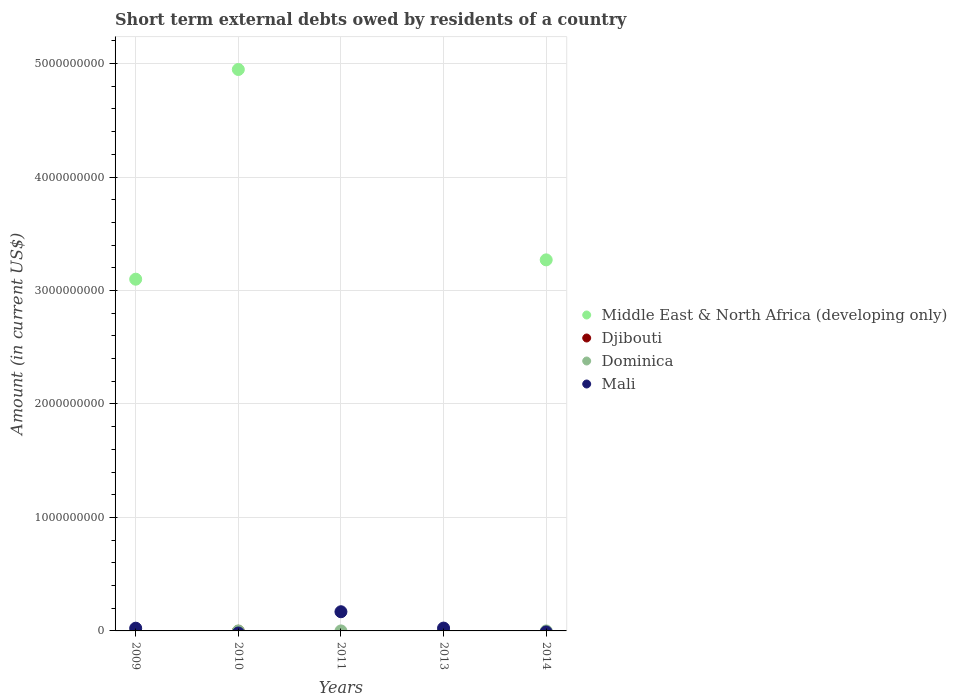Across all years, what is the maximum amount of short-term external debts owed by residents in Middle East & North Africa (developing only)?
Provide a succinct answer. 4.95e+09. Across all years, what is the minimum amount of short-term external debts owed by residents in Middle East & North Africa (developing only)?
Offer a terse response. 0. In which year was the amount of short-term external debts owed by residents in Dominica maximum?
Provide a succinct answer. 2011. What is the total amount of short-term external debts owed by residents in Mali in the graph?
Offer a terse response. 2.18e+08. What is the difference between the amount of short-term external debts owed by residents in Middle East & North Africa (developing only) in 2009 and that in 2010?
Give a very brief answer. -1.85e+09. What is the average amount of short-term external debts owed by residents in Mali per year?
Provide a succinct answer. 4.36e+07. In the year 2013, what is the difference between the amount of short-term external debts owed by residents in Dominica and amount of short-term external debts owed by residents in Mali?
Provide a succinct answer. -2.50e+07. In how many years, is the amount of short-term external debts owed by residents in Middle East & North Africa (developing only) greater than 1800000000 US$?
Offer a very short reply. 3. What is the difference between the highest and the second highest amount of short-term external debts owed by residents in Mali?
Your answer should be very brief. 1.44e+08. What is the difference between the highest and the lowest amount of short-term external debts owed by residents in Middle East & North Africa (developing only)?
Ensure brevity in your answer.  4.95e+09. In how many years, is the amount of short-term external debts owed by residents in Djibouti greater than the average amount of short-term external debts owed by residents in Djibouti taken over all years?
Give a very brief answer. 0. Is the sum of the amount of short-term external debts owed by residents in Mali in 2011 and 2013 greater than the maximum amount of short-term external debts owed by residents in Middle East & North Africa (developing only) across all years?
Your answer should be very brief. No. Is it the case that in every year, the sum of the amount of short-term external debts owed by residents in Dominica and amount of short-term external debts owed by residents in Middle East & North Africa (developing only)  is greater than the sum of amount of short-term external debts owed by residents in Mali and amount of short-term external debts owed by residents in Djibouti?
Offer a very short reply. No. Does the amount of short-term external debts owed by residents in Middle East & North Africa (developing only) monotonically increase over the years?
Your answer should be very brief. No. Is the amount of short-term external debts owed by residents in Dominica strictly greater than the amount of short-term external debts owed by residents in Middle East & North Africa (developing only) over the years?
Your answer should be compact. No. How many years are there in the graph?
Your response must be concise. 5. Does the graph contain any zero values?
Give a very brief answer. Yes. Where does the legend appear in the graph?
Provide a succinct answer. Center right. How many legend labels are there?
Offer a terse response. 4. How are the legend labels stacked?
Your response must be concise. Vertical. What is the title of the graph?
Your answer should be compact. Short term external debts owed by residents of a country. Does "Ghana" appear as one of the legend labels in the graph?
Your answer should be compact. No. What is the Amount (in current US$) in Middle East & North Africa (developing only) in 2009?
Keep it short and to the point. 3.10e+09. What is the Amount (in current US$) in Djibouti in 2009?
Offer a very short reply. 0. What is the Amount (in current US$) in Mali in 2009?
Provide a succinct answer. 2.40e+07. What is the Amount (in current US$) of Middle East & North Africa (developing only) in 2010?
Your response must be concise. 4.95e+09. What is the Amount (in current US$) in Mali in 2010?
Offer a terse response. 0. What is the Amount (in current US$) of Middle East & North Africa (developing only) in 2011?
Give a very brief answer. 0. What is the Amount (in current US$) of Djibouti in 2011?
Keep it short and to the point. 0. What is the Amount (in current US$) of Dominica in 2011?
Offer a very short reply. 10000. What is the Amount (in current US$) of Mali in 2011?
Offer a terse response. 1.69e+08. What is the Amount (in current US$) in Middle East & North Africa (developing only) in 2013?
Ensure brevity in your answer.  0. What is the Amount (in current US$) of Djibouti in 2013?
Your response must be concise. 0. What is the Amount (in current US$) of Dominica in 2013?
Offer a terse response. 4000. What is the Amount (in current US$) of Mali in 2013?
Give a very brief answer. 2.50e+07. What is the Amount (in current US$) of Middle East & North Africa (developing only) in 2014?
Offer a very short reply. 3.27e+09. What is the Amount (in current US$) of Dominica in 2014?
Offer a terse response. 0. What is the Amount (in current US$) of Mali in 2014?
Offer a very short reply. 0. Across all years, what is the maximum Amount (in current US$) of Middle East & North Africa (developing only)?
Keep it short and to the point. 4.95e+09. Across all years, what is the maximum Amount (in current US$) of Mali?
Offer a very short reply. 1.69e+08. What is the total Amount (in current US$) of Middle East & North Africa (developing only) in the graph?
Offer a very short reply. 1.13e+1. What is the total Amount (in current US$) in Dominica in the graph?
Make the answer very short. 1.40e+04. What is the total Amount (in current US$) of Mali in the graph?
Ensure brevity in your answer.  2.18e+08. What is the difference between the Amount (in current US$) in Middle East & North Africa (developing only) in 2009 and that in 2010?
Your answer should be very brief. -1.85e+09. What is the difference between the Amount (in current US$) in Mali in 2009 and that in 2011?
Offer a very short reply. -1.45e+08. What is the difference between the Amount (in current US$) of Mali in 2009 and that in 2013?
Provide a succinct answer. -1.00e+06. What is the difference between the Amount (in current US$) in Middle East & North Africa (developing only) in 2009 and that in 2014?
Offer a very short reply. -1.70e+08. What is the difference between the Amount (in current US$) of Middle East & North Africa (developing only) in 2010 and that in 2014?
Give a very brief answer. 1.68e+09. What is the difference between the Amount (in current US$) in Dominica in 2011 and that in 2013?
Keep it short and to the point. 6000. What is the difference between the Amount (in current US$) of Mali in 2011 and that in 2013?
Your answer should be compact. 1.44e+08. What is the difference between the Amount (in current US$) in Middle East & North Africa (developing only) in 2009 and the Amount (in current US$) in Dominica in 2011?
Your answer should be compact. 3.10e+09. What is the difference between the Amount (in current US$) in Middle East & North Africa (developing only) in 2009 and the Amount (in current US$) in Mali in 2011?
Offer a terse response. 2.93e+09. What is the difference between the Amount (in current US$) in Middle East & North Africa (developing only) in 2009 and the Amount (in current US$) in Dominica in 2013?
Keep it short and to the point. 3.10e+09. What is the difference between the Amount (in current US$) of Middle East & North Africa (developing only) in 2009 and the Amount (in current US$) of Mali in 2013?
Give a very brief answer. 3.07e+09. What is the difference between the Amount (in current US$) of Middle East & North Africa (developing only) in 2010 and the Amount (in current US$) of Dominica in 2011?
Your answer should be compact. 4.95e+09. What is the difference between the Amount (in current US$) in Middle East & North Africa (developing only) in 2010 and the Amount (in current US$) in Mali in 2011?
Your answer should be very brief. 4.78e+09. What is the difference between the Amount (in current US$) in Middle East & North Africa (developing only) in 2010 and the Amount (in current US$) in Dominica in 2013?
Keep it short and to the point. 4.95e+09. What is the difference between the Amount (in current US$) in Middle East & North Africa (developing only) in 2010 and the Amount (in current US$) in Mali in 2013?
Offer a very short reply. 4.92e+09. What is the difference between the Amount (in current US$) of Dominica in 2011 and the Amount (in current US$) of Mali in 2013?
Give a very brief answer. -2.50e+07. What is the average Amount (in current US$) of Middle East & North Africa (developing only) per year?
Provide a succinct answer. 2.26e+09. What is the average Amount (in current US$) of Dominica per year?
Ensure brevity in your answer.  2800. What is the average Amount (in current US$) in Mali per year?
Offer a very short reply. 4.36e+07. In the year 2009, what is the difference between the Amount (in current US$) of Middle East & North Africa (developing only) and Amount (in current US$) of Mali?
Make the answer very short. 3.08e+09. In the year 2011, what is the difference between the Amount (in current US$) in Dominica and Amount (in current US$) in Mali?
Make the answer very short. -1.69e+08. In the year 2013, what is the difference between the Amount (in current US$) of Dominica and Amount (in current US$) of Mali?
Offer a terse response. -2.50e+07. What is the ratio of the Amount (in current US$) in Middle East & North Africa (developing only) in 2009 to that in 2010?
Give a very brief answer. 0.63. What is the ratio of the Amount (in current US$) in Mali in 2009 to that in 2011?
Provide a short and direct response. 0.14. What is the ratio of the Amount (in current US$) in Middle East & North Africa (developing only) in 2009 to that in 2014?
Keep it short and to the point. 0.95. What is the ratio of the Amount (in current US$) of Middle East & North Africa (developing only) in 2010 to that in 2014?
Give a very brief answer. 1.51. What is the ratio of the Amount (in current US$) of Dominica in 2011 to that in 2013?
Make the answer very short. 2.5. What is the ratio of the Amount (in current US$) of Mali in 2011 to that in 2013?
Your answer should be compact. 6.76. What is the difference between the highest and the second highest Amount (in current US$) in Middle East & North Africa (developing only)?
Provide a short and direct response. 1.68e+09. What is the difference between the highest and the second highest Amount (in current US$) in Mali?
Make the answer very short. 1.44e+08. What is the difference between the highest and the lowest Amount (in current US$) of Middle East & North Africa (developing only)?
Provide a succinct answer. 4.95e+09. What is the difference between the highest and the lowest Amount (in current US$) of Mali?
Your answer should be very brief. 1.69e+08. 